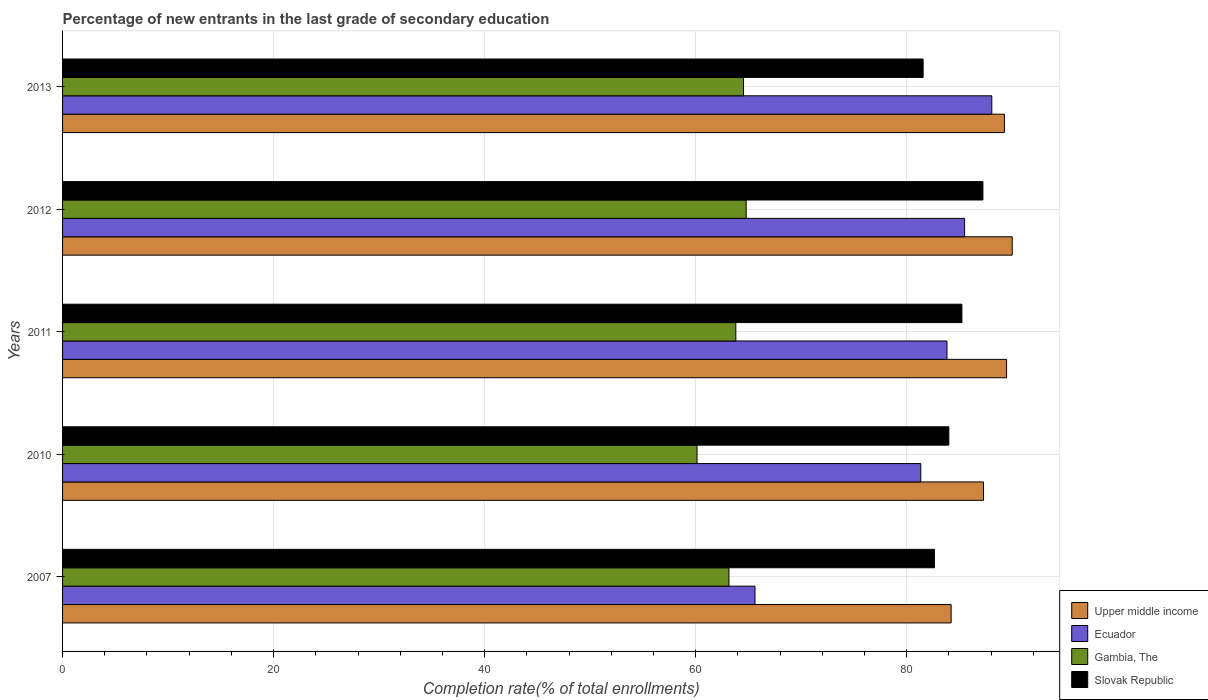How many different coloured bars are there?
Provide a succinct answer. 4. Are the number of bars on each tick of the Y-axis equal?
Provide a short and direct response. Yes. How many bars are there on the 4th tick from the top?
Offer a terse response. 4. How many bars are there on the 4th tick from the bottom?
Your answer should be very brief. 4. What is the label of the 3rd group of bars from the top?
Give a very brief answer. 2011. What is the percentage of new entrants in Slovak Republic in 2011?
Provide a short and direct response. 85.23. Across all years, what is the maximum percentage of new entrants in Slovak Republic?
Provide a short and direct response. 87.23. Across all years, what is the minimum percentage of new entrants in Upper middle income?
Your answer should be compact. 84.21. What is the total percentage of new entrants in Gambia, The in the graph?
Offer a terse response. 316.43. What is the difference between the percentage of new entrants in Slovak Republic in 2010 and that in 2012?
Offer a very short reply. -3.23. What is the difference between the percentage of new entrants in Upper middle income in 2013 and the percentage of new entrants in Ecuador in 2012?
Provide a short and direct response. 3.77. What is the average percentage of new entrants in Ecuador per year?
Your answer should be compact. 80.87. In the year 2013, what is the difference between the percentage of new entrants in Gambia, The and percentage of new entrants in Slovak Republic?
Your answer should be very brief. -17.02. What is the ratio of the percentage of new entrants in Slovak Republic in 2012 to that in 2013?
Provide a short and direct response. 1.07. Is the percentage of new entrants in Upper middle income in 2007 less than that in 2010?
Offer a very short reply. Yes. Is the difference between the percentage of new entrants in Gambia, The in 2007 and 2010 greater than the difference between the percentage of new entrants in Slovak Republic in 2007 and 2010?
Ensure brevity in your answer.  Yes. What is the difference between the highest and the second highest percentage of new entrants in Upper middle income?
Your response must be concise. 0.53. What is the difference between the highest and the lowest percentage of new entrants in Ecuador?
Provide a succinct answer. 22.44. In how many years, is the percentage of new entrants in Upper middle income greater than the average percentage of new entrants in Upper middle income taken over all years?
Your answer should be compact. 3. Is the sum of the percentage of new entrants in Gambia, The in 2007 and 2013 greater than the maximum percentage of new entrants in Upper middle income across all years?
Make the answer very short. Yes. Is it the case that in every year, the sum of the percentage of new entrants in Slovak Republic and percentage of new entrants in Ecuador is greater than the sum of percentage of new entrants in Upper middle income and percentage of new entrants in Gambia, The?
Your answer should be compact. No. What does the 1st bar from the top in 2007 represents?
Offer a terse response. Slovak Republic. What does the 2nd bar from the bottom in 2007 represents?
Make the answer very short. Ecuador. Is it the case that in every year, the sum of the percentage of new entrants in Gambia, The and percentage of new entrants in Upper middle income is greater than the percentage of new entrants in Slovak Republic?
Your answer should be compact. Yes. Are all the bars in the graph horizontal?
Make the answer very short. Yes. What is the difference between two consecutive major ticks on the X-axis?
Offer a very short reply. 20. How are the legend labels stacked?
Your response must be concise. Vertical. What is the title of the graph?
Give a very brief answer. Percentage of new entrants in the last grade of secondary education. What is the label or title of the X-axis?
Offer a very short reply. Completion rate(% of total enrollments). What is the label or title of the Y-axis?
Your answer should be very brief. Years. What is the Completion rate(% of total enrollments) in Upper middle income in 2007?
Your response must be concise. 84.21. What is the Completion rate(% of total enrollments) of Ecuador in 2007?
Your response must be concise. 65.63. What is the Completion rate(% of total enrollments) in Gambia, The in 2007?
Your response must be concise. 63.16. What is the Completion rate(% of total enrollments) in Slovak Republic in 2007?
Offer a very short reply. 82.63. What is the Completion rate(% of total enrollments) in Upper middle income in 2010?
Your response must be concise. 87.28. What is the Completion rate(% of total enrollments) in Ecuador in 2010?
Make the answer very short. 81.34. What is the Completion rate(% of total enrollments) of Gambia, The in 2010?
Give a very brief answer. 60.13. What is the Completion rate(% of total enrollments) of Slovak Republic in 2010?
Offer a very short reply. 84. What is the Completion rate(% of total enrollments) in Upper middle income in 2011?
Your response must be concise. 89.47. What is the Completion rate(% of total enrollments) in Ecuador in 2011?
Give a very brief answer. 83.82. What is the Completion rate(% of total enrollments) in Gambia, The in 2011?
Make the answer very short. 63.81. What is the Completion rate(% of total enrollments) in Slovak Republic in 2011?
Your answer should be compact. 85.23. What is the Completion rate(% of total enrollments) in Upper middle income in 2012?
Your answer should be compact. 90. What is the Completion rate(% of total enrollments) of Ecuador in 2012?
Offer a very short reply. 85.49. What is the Completion rate(% of total enrollments) of Gambia, The in 2012?
Ensure brevity in your answer.  64.79. What is the Completion rate(% of total enrollments) of Slovak Republic in 2012?
Offer a terse response. 87.23. What is the Completion rate(% of total enrollments) of Upper middle income in 2013?
Keep it short and to the point. 89.26. What is the Completion rate(% of total enrollments) of Ecuador in 2013?
Your answer should be very brief. 88.07. What is the Completion rate(% of total enrollments) in Gambia, The in 2013?
Offer a very short reply. 64.54. What is the Completion rate(% of total enrollments) of Slovak Republic in 2013?
Your response must be concise. 81.56. Across all years, what is the maximum Completion rate(% of total enrollments) in Upper middle income?
Provide a short and direct response. 90. Across all years, what is the maximum Completion rate(% of total enrollments) in Ecuador?
Offer a terse response. 88.07. Across all years, what is the maximum Completion rate(% of total enrollments) in Gambia, The?
Your answer should be very brief. 64.79. Across all years, what is the maximum Completion rate(% of total enrollments) in Slovak Republic?
Offer a terse response. 87.23. Across all years, what is the minimum Completion rate(% of total enrollments) of Upper middle income?
Your answer should be very brief. 84.21. Across all years, what is the minimum Completion rate(% of total enrollments) of Ecuador?
Give a very brief answer. 65.63. Across all years, what is the minimum Completion rate(% of total enrollments) of Gambia, The?
Offer a very short reply. 60.13. Across all years, what is the minimum Completion rate(% of total enrollments) of Slovak Republic?
Provide a succinct answer. 81.56. What is the total Completion rate(% of total enrollments) of Upper middle income in the graph?
Your answer should be very brief. 440.23. What is the total Completion rate(% of total enrollments) of Ecuador in the graph?
Offer a very short reply. 404.34. What is the total Completion rate(% of total enrollments) in Gambia, The in the graph?
Your answer should be very brief. 316.43. What is the total Completion rate(% of total enrollments) in Slovak Republic in the graph?
Your response must be concise. 420.65. What is the difference between the Completion rate(% of total enrollments) in Upper middle income in 2007 and that in 2010?
Your answer should be compact. -3.07. What is the difference between the Completion rate(% of total enrollments) in Ecuador in 2007 and that in 2010?
Provide a succinct answer. -15.71. What is the difference between the Completion rate(% of total enrollments) in Gambia, The in 2007 and that in 2010?
Ensure brevity in your answer.  3.02. What is the difference between the Completion rate(% of total enrollments) of Slovak Republic in 2007 and that in 2010?
Make the answer very short. -1.37. What is the difference between the Completion rate(% of total enrollments) in Upper middle income in 2007 and that in 2011?
Provide a succinct answer. -5.25. What is the difference between the Completion rate(% of total enrollments) of Ecuador in 2007 and that in 2011?
Ensure brevity in your answer.  -18.2. What is the difference between the Completion rate(% of total enrollments) of Gambia, The in 2007 and that in 2011?
Offer a terse response. -0.65. What is the difference between the Completion rate(% of total enrollments) in Slovak Republic in 2007 and that in 2011?
Offer a terse response. -2.6. What is the difference between the Completion rate(% of total enrollments) of Upper middle income in 2007 and that in 2012?
Ensure brevity in your answer.  -5.79. What is the difference between the Completion rate(% of total enrollments) of Ecuador in 2007 and that in 2012?
Your answer should be very brief. -19.86. What is the difference between the Completion rate(% of total enrollments) of Gambia, The in 2007 and that in 2012?
Provide a short and direct response. -1.63. What is the difference between the Completion rate(% of total enrollments) of Slovak Republic in 2007 and that in 2012?
Your answer should be compact. -4.6. What is the difference between the Completion rate(% of total enrollments) in Upper middle income in 2007 and that in 2013?
Keep it short and to the point. -5.05. What is the difference between the Completion rate(% of total enrollments) of Ecuador in 2007 and that in 2013?
Your answer should be very brief. -22.44. What is the difference between the Completion rate(% of total enrollments) in Gambia, The in 2007 and that in 2013?
Keep it short and to the point. -1.38. What is the difference between the Completion rate(% of total enrollments) in Slovak Republic in 2007 and that in 2013?
Your answer should be compact. 1.07. What is the difference between the Completion rate(% of total enrollments) of Upper middle income in 2010 and that in 2011?
Make the answer very short. -2.19. What is the difference between the Completion rate(% of total enrollments) of Ecuador in 2010 and that in 2011?
Your response must be concise. -2.48. What is the difference between the Completion rate(% of total enrollments) of Gambia, The in 2010 and that in 2011?
Keep it short and to the point. -3.67. What is the difference between the Completion rate(% of total enrollments) of Slovak Republic in 2010 and that in 2011?
Ensure brevity in your answer.  -1.24. What is the difference between the Completion rate(% of total enrollments) of Upper middle income in 2010 and that in 2012?
Provide a short and direct response. -2.72. What is the difference between the Completion rate(% of total enrollments) of Ecuador in 2010 and that in 2012?
Make the answer very short. -4.15. What is the difference between the Completion rate(% of total enrollments) in Gambia, The in 2010 and that in 2012?
Offer a terse response. -4.66. What is the difference between the Completion rate(% of total enrollments) in Slovak Republic in 2010 and that in 2012?
Give a very brief answer. -3.23. What is the difference between the Completion rate(% of total enrollments) in Upper middle income in 2010 and that in 2013?
Your answer should be compact. -1.98. What is the difference between the Completion rate(% of total enrollments) in Ecuador in 2010 and that in 2013?
Make the answer very short. -6.73. What is the difference between the Completion rate(% of total enrollments) in Gambia, The in 2010 and that in 2013?
Offer a terse response. -4.41. What is the difference between the Completion rate(% of total enrollments) of Slovak Republic in 2010 and that in 2013?
Give a very brief answer. 2.44. What is the difference between the Completion rate(% of total enrollments) in Upper middle income in 2011 and that in 2012?
Your answer should be very brief. -0.53. What is the difference between the Completion rate(% of total enrollments) of Ecuador in 2011 and that in 2012?
Provide a short and direct response. -1.67. What is the difference between the Completion rate(% of total enrollments) in Gambia, The in 2011 and that in 2012?
Your answer should be very brief. -0.98. What is the difference between the Completion rate(% of total enrollments) in Slovak Republic in 2011 and that in 2012?
Provide a short and direct response. -1.99. What is the difference between the Completion rate(% of total enrollments) of Upper middle income in 2011 and that in 2013?
Keep it short and to the point. 0.2. What is the difference between the Completion rate(% of total enrollments) in Ecuador in 2011 and that in 2013?
Give a very brief answer. -4.25. What is the difference between the Completion rate(% of total enrollments) in Gambia, The in 2011 and that in 2013?
Your answer should be very brief. -0.73. What is the difference between the Completion rate(% of total enrollments) in Slovak Republic in 2011 and that in 2013?
Offer a very short reply. 3.67. What is the difference between the Completion rate(% of total enrollments) in Upper middle income in 2012 and that in 2013?
Offer a very short reply. 0.74. What is the difference between the Completion rate(% of total enrollments) of Ecuador in 2012 and that in 2013?
Make the answer very short. -2.58. What is the difference between the Completion rate(% of total enrollments) of Gambia, The in 2012 and that in 2013?
Provide a short and direct response. 0.25. What is the difference between the Completion rate(% of total enrollments) in Slovak Republic in 2012 and that in 2013?
Provide a short and direct response. 5.67. What is the difference between the Completion rate(% of total enrollments) in Upper middle income in 2007 and the Completion rate(% of total enrollments) in Ecuador in 2010?
Provide a succinct answer. 2.88. What is the difference between the Completion rate(% of total enrollments) in Upper middle income in 2007 and the Completion rate(% of total enrollments) in Gambia, The in 2010?
Offer a terse response. 24.08. What is the difference between the Completion rate(% of total enrollments) in Upper middle income in 2007 and the Completion rate(% of total enrollments) in Slovak Republic in 2010?
Provide a succinct answer. 0.22. What is the difference between the Completion rate(% of total enrollments) in Ecuador in 2007 and the Completion rate(% of total enrollments) in Gambia, The in 2010?
Make the answer very short. 5.49. What is the difference between the Completion rate(% of total enrollments) in Ecuador in 2007 and the Completion rate(% of total enrollments) in Slovak Republic in 2010?
Your answer should be very brief. -18.37. What is the difference between the Completion rate(% of total enrollments) of Gambia, The in 2007 and the Completion rate(% of total enrollments) of Slovak Republic in 2010?
Provide a short and direct response. -20.84. What is the difference between the Completion rate(% of total enrollments) of Upper middle income in 2007 and the Completion rate(% of total enrollments) of Ecuador in 2011?
Your answer should be very brief. 0.39. What is the difference between the Completion rate(% of total enrollments) in Upper middle income in 2007 and the Completion rate(% of total enrollments) in Gambia, The in 2011?
Give a very brief answer. 20.41. What is the difference between the Completion rate(% of total enrollments) of Upper middle income in 2007 and the Completion rate(% of total enrollments) of Slovak Republic in 2011?
Your response must be concise. -1.02. What is the difference between the Completion rate(% of total enrollments) in Ecuador in 2007 and the Completion rate(% of total enrollments) in Gambia, The in 2011?
Your response must be concise. 1.82. What is the difference between the Completion rate(% of total enrollments) in Ecuador in 2007 and the Completion rate(% of total enrollments) in Slovak Republic in 2011?
Make the answer very short. -19.61. What is the difference between the Completion rate(% of total enrollments) of Gambia, The in 2007 and the Completion rate(% of total enrollments) of Slovak Republic in 2011?
Your answer should be compact. -22.08. What is the difference between the Completion rate(% of total enrollments) of Upper middle income in 2007 and the Completion rate(% of total enrollments) of Ecuador in 2012?
Offer a terse response. -1.28. What is the difference between the Completion rate(% of total enrollments) of Upper middle income in 2007 and the Completion rate(% of total enrollments) of Gambia, The in 2012?
Your answer should be very brief. 19.43. What is the difference between the Completion rate(% of total enrollments) of Upper middle income in 2007 and the Completion rate(% of total enrollments) of Slovak Republic in 2012?
Your answer should be compact. -3.01. What is the difference between the Completion rate(% of total enrollments) in Ecuador in 2007 and the Completion rate(% of total enrollments) in Gambia, The in 2012?
Offer a terse response. 0.84. What is the difference between the Completion rate(% of total enrollments) in Ecuador in 2007 and the Completion rate(% of total enrollments) in Slovak Republic in 2012?
Offer a terse response. -21.6. What is the difference between the Completion rate(% of total enrollments) of Gambia, The in 2007 and the Completion rate(% of total enrollments) of Slovak Republic in 2012?
Make the answer very short. -24.07. What is the difference between the Completion rate(% of total enrollments) of Upper middle income in 2007 and the Completion rate(% of total enrollments) of Ecuador in 2013?
Your answer should be very brief. -3.86. What is the difference between the Completion rate(% of total enrollments) of Upper middle income in 2007 and the Completion rate(% of total enrollments) of Gambia, The in 2013?
Ensure brevity in your answer.  19.67. What is the difference between the Completion rate(% of total enrollments) of Upper middle income in 2007 and the Completion rate(% of total enrollments) of Slovak Republic in 2013?
Provide a succinct answer. 2.65. What is the difference between the Completion rate(% of total enrollments) of Ecuador in 2007 and the Completion rate(% of total enrollments) of Gambia, The in 2013?
Give a very brief answer. 1.09. What is the difference between the Completion rate(% of total enrollments) in Ecuador in 2007 and the Completion rate(% of total enrollments) in Slovak Republic in 2013?
Provide a short and direct response. -15.93. What is the difference between the Completion rate(% of total enrollments) in Gambia, The in 2007 and the Completion rate(% of total enrollments) in Slovak Republic in 2013?
Your response must be concise. -18.4. What is the difference between the Completion rate(% of total enrollments) of Upper middle income in 2010 and the Completion rate(% of total enrollments) of Ecuador in 2011?
Offer a terse response. 3.46. What is the difference between the Completion rate(% of total enrollments) of Upper middle income in 2010 and the Completion rate(% of total enrollments) of Gambia, The in 2011?
Make the answer very short. 23.47. What is the difference between the Completion rate(% of total enrollments) of Upper middle income in 2010 and the Completion rate(% of total enrollments) of Slovak Republic in 2011?
Ensure brevity in your answer.  2.05. What is the difference between the Completion rate(% of total enrollments) in Ecuador in 2010 and the Completion rate(% of total enrollments) in Gambia, The in 2011?
Your answer should be compact. 17.53. What is the difference between the Completion rate(% of total enrollments) of Ecuador in 2010 and the Completion rate(% of total enrollments) of Slovak Republic in 2011?
Offer a very short reply. -3.9. What is the difference between the Completion rate(% of total enrollments) in Gambia, The in 2010 and the Completion rate(% of total enrollments) in Slovak Republic in 2011?
Ensure brevity in your answer.  -25.1. What is the difference between the Completion rate(% of total enrollments) of Upper middle income in 2010 and the Completion rate(% of total enrollments) of Ecuador in 2012?
Ensure brevity in your answer.  1.79. What is the difference between the Completion rate(% of total enrollments) of Upper middle income in 2010 and the Completion rate(% of total enrollments) of Gambia, The in 2012?
Offer a terse response. 22.49. What is the difference between the Completion rate(% of total enrollments) in Upper middle income in 2010 and the Completion rate(% of total enrollments) in Slovak Republic in 2012?
Offer a terse response. 0.05. What is the difference between the Completion rate(% of total enrollments) in Ecuador in 2010 and the Completion rate(% of total enrollments) in Gambia, The in 2012?
Make the answer very short. 16.55. What is the difference between the Completion rate(% of total enrollments) of Ecuador in 2010 and the Completion rate(% of total enrollments) of Slovak Republic in 2012?
Offer a very short reply. -5.89. What is the difference between the Completion rate(% of total enrollments) in Gambia, The in 2010 and the Completion rate(% of total enrollments) in Slovak Republic in 2012?
Provide a short and direct response. -27.09. What is the difference between the Completion rate(% of total enrollments) of Upper middle income in 2010 and the Completion rate(% of total enrollments) of Ecuador in 2013?
Give a very brief answer. -0.79. What is the difference between the Completion rate(% of total enrollments) in Upper middle income in 2010 and the Completion rate(% of total enrollments) in Gambia, The in 2013?
Ensure brevity in your answer.  22.74. What is the difference between the Completion rate(% of total enrollments) of Upper middle income in 2010 and the Completion rate(% of total enrollments) of Slovak Republic in 2013?
Your answer should be very brief. 5.72. What is the difference between the Completion rate(% of total enrollments) in Ecuador in 2010 and the Completion rate(% of total enrollments) in Gambia, The in 2013?
Offer a terse response. 16.8. What is the difference between the Completion rate(% of total enrollments) in Ecuador in 2010 and the Completion rate(% of total enrollments) in Slovak Republic in 2013?
Your response must be concise. -0.22. What is the difference between the Completion rate(% of total enrollments) of Gambia, The in 2010 and the Completion rate(% of total enrollments) of Slovak Republic in 2013?
Your response must be concise. -21.43. What is the difference between the Completion rate(% of total enrollments) in Upper middle income in 2011 and the Completion rate(% of total enrollments) in Ecuador in 2012?
Offer a very short reply. 3.98. What is the difference between the Completion rate(% of total enrollments) of Upper middle income in 2011 and the Completion rate(% of total enrollments) of Gambia, The in 2012?
Ensure brevity in your answer.  24.68. What is the difference between the Completion rate(% of total enrollments) of Upper middle income in 2011 and the Completion rate(% of total enrollments) of Slovak Republic in 2012?
Provide a short and direct response. 2.24. What is the difference between the Completion rate(% of total enrollments) of Ecuador in 2011 and the Completion rate(% of total enrollments) of Gambia, The in 2012?
Offer a terse response. 19.03. What is the difference between the Completion rate(% of total enrollments) of Ecuador in 2011 and the Completion rate(% of total enrollments) of Slovak Republic in 2012?
Make the answer very short. -3.41. What is the difference between the Completion rate(% of total enrollments) in Gambia, The in 2011 and the Completion rate(% of total enrollments) in Slovak Republic in 2012?
Provide a short and direct response. -23.42. What is the difference between the Completion rate(% of total enrollments) of Upper middle income in 2011 and the Completion rate(% of total enrollments) of Ecuador in 2013?
Give a very brief answer. 1.4. What is the difference between the Completion rate(% of total enrollments) of Upper middle income in 2011 and the Completion rate(% of total enrollments) of Gambia, The in 2013?
Your response must be concise. 24.93. What is the difference between the Completion rate(% of total enrollments) in Upper middle income in 2011 and the Completion rate(% of total enrollments) in Slovak Republic in 2013?
Ensure brevity in your answer.  7.91. What is the difference between the Completion rate(% of total enrollments) in Ecuador in 2011 and the Completion rate(% of total enrollments) in Gambia, The in 2013?
Provide a short and direct response. 19.28. What is the difference between the Completion rate(% of total enrollments) in Ecuador in 2011 and the Completion rate(% of total enrollments) in Slovak Republic in 2013?
Ensure brevity in your answer.  2.26. What is the difference between the Completion rate(% of total enrollments) in Gambia, The in 2011 and the Completion rate(% of total enrollments) in Slovak Republic in 2013?
Make the answer very short. -17.75. What is the difference between the Completion rate(% of total enrollments) in Upper middle income in 2012 and the Completion rate(% of total enrollments) in Ecuador in 2013?
Your response must be concise. 1.93. What is the difference between the Completion rate(% of total enrollments) in Upper middle income in 2012 and the Completion rate(% of total enrollments) in Gambia, The in 2013?
Provide a succinct answer. 25.46. What is the difference between the Completion rate(% of total enrollments) in Upper middle income in 2012 and the Completion rate(% of total enrollments) in Slovak Republic in 2013?
Make the answer very short. 8.44. What is the difference between the Completion rate(% of total enrollments) of Ecuador in 2012 and the Completion rate(% of total enrollments) of Gambia, The in 2013?
Your response must be concise. 20.95. What is the difference between the Completion rate(% of total enrollments) in Ecuador in 2012 and the Completion rate(% of total enrollments) in Slovak Republic in 2013?
Offer a very short reply. 3.93. What is the difference between the Completion rate(% of total enrollments) of Gambia, The in 2012 and the Completion rate(% of total enrollments) of Slovak Republic in 2013?
Ensure brevity in your answer.  -16.77. What is the average Completion rate(% of total enrollments) in Upper middle income per year?
Your answer should be very brief. 88.05. What is the average Completion rate(% of total enrollments) of Ecuador per year?
Make the answer very short. 80.87. What is the average Completion rate(% of total enrollments) of Gambia, The per year?
Your answer should be compact. 63.29. What is the average Completion rate(% of total enrollments) of Slovak Republic per year?
Provide a succinct answer. 84.13. In the year 2007, what is the difference between the Completion rate(% of total enrollments) in Upper middle income and Completion rate(% of total enrollments) in Ecuador?
Ensure brevity in your answer.  18.59. In the year 2007, what is the difference between the Completion rate(% of total enrollments) of Upper middle income and Completion rate(% of total enrollments) of Gambia, The?
Your answer should be compact. 21.06. In the year 2007, what is the difference between the Completion rate(% of total enrollments) in Upper middle income and Completion rate(% of total enrollments) in Slovak Republic?
Offer a terse response. 1.58. In the year 2007, what is the difference between the Completion rate(% of total enrollments) of Ecuador and Completion rate(% of total enrollments) of Gambia, The?
Ensure brevity in your answer.  2.47. In the year 2007, what is the difference between the Completion rate(% of total enrollments) of Ecuador and Completion rate(% of total enrollments) of Slovak Republic?
Make the answer very short. -17.01. In the year 2007, what is the difference between the Completion rate(% of total enrollments) in Gambia, The and Completion rate(% of total enrollments) in Slovak Republic?
Your answer should be very brief. -19.47. In the year 2010, what is the difference between the Completion rate(% of total enrollments) of Upper middle income and Completion rate(% of total enrollments) of Ecuador?
Your answer should be very brief. 5.95. In the year 2010, what is the difference between the Completion rate(% of total enrollments) of Upper middle income and Completion rate(% of total enrollments) of Gambia, The?
Give a very brief answer. 27.15. In the year 2010, what is the difference between the Completion rate(% of total enrollments) of Upper middle income and Completion rate(% of total enrollments) of Slovak Republic?
Offer a very short reply. 3.28. In the year 2010, what is the difference between the Completion rate(% of total enrollments) of Ecuador and Completion rate(% of total enrollments) of Gambia, The?
Provide a succinct answer. 21.2. In the year 2010, what is the difference between the Completion rate(% of total enrollments) in Ecuador and Completion rate(% of total enrollments) in Slovak Republic?
Provide a short and direct response. -2.66. In the year 2010, what is the difference between the Completion rate(% of total enrollments) in Gambia, The and Completion rate(% of total enrollments) in Slovak Republic?
Provide a short and direct response. -23.86. In the year 2011, what is the difference between the Completion rate(% of total enrollments) in Upper middle income and Completion rate(% of total enrollments) in Ecuador?
Ensure brevity in your answer.  5.65. In the year 2011, what is the difference between the Completion rate(% of total enrollments) in Upper middle income and Completion rate(% of total enrollments) in Gambia, The?
Your answer should be very brief. 25.66. In the year 2011, what is the difference between the Completion rate(% of total enrollments) of Upper middle income and Completion rate(% of total enrollments) of Slovak Republic?
Give a very brief answer. 4.23. In the year 2011, what is the difference between the Completion rate(% of total enrollments) in Ecuador and Completion rate(% of total enrollments) in Gambia, The?
Keep it short and to the point. 20.01. In the year 2011, what is the difference between the Completion rate(% of total enrollments) in Ecuador and Completion rate(% of total enrollments) in Slovak Republic?
Your response must be concise. -1.41. In the year 2011, what is the difference between the Completion rate(% of total enrollments) in Gambia, The and Completion rate(% of total enrollments) in Slovak Republic?
Ensure brevity in your answer.  -21.43. In the year 2012, what is the difference between the Completion rate(% of total enrollments) in Upper middle income and Completion rate(% of total enrollments) in Ecuador?
Ensure brevity in your answer.  4.51. In the year 2012, what is the difference between the Completion rate(% of total enrollments) in Upper middle income and Completion rate(% of total enrollments) in Gambia, The?
Keep it short and to the point. 25.21. In the year 2012, what is the difference between the Completion rate(% of total enrollments) in Upper middle income and Completion rate(% of total enrollments) in Slovak Republic?
Make the answer very short. 2.78. In the year 2012, what is the difference between the Completion rate(% of total enrollments) in Ecuador and Completion rate(% of total enrollments) in Gambia, The?
Make the answer very short. 20.7. In the year 2012, what is the difference between the Completion rate(% of total enrollments) of Ecuador and Completion rate(% of total enrollments) of Slovak Republic?
Your response must be concise. -1.74. In the year 2012, what is the difference between the Completion rate(% of total enrollments) of Gambia, The and Completion rate(% of total enrollments) of Slovak Republic?
Your answer should be very brief. -22.44. In the year 2013, what is the difference between the Completion rate(% of total enrollments) of Upper middle income and Completion rate(% of total enrollments) of Ecuador?
Make the answer very short. 1.19. In the year 2013, what is the difference between the Completion rate(% of total enrollments) of Upper middle income and Completion rate(% of total enrollments) of Gambia, The?
Your response must be concise. 24.72. In the year 2013, what is the difference between the Completion rate(% of total enrollments) of Upper middle income and Completion rate(% of total enrollments) of Slovak Republic?
Keep it short and to the point. 7.7. In the year 2013, what is the difference between the Completion rate(% of total enrollments) of Ecuador and Completion rate(% of total enrollments) of Gambia, The?
Provide a succinct answer. 23.53. In the year 2013, what is the difference between the Completion rate(% of total enrollments) of Ecuador and Completion rate(% of total enrollments) of Slovak Republic?
Offer a terse response. 6.51. In the year 2013, what is the difference between the Completion rate(% of total enrollments) in Gambia, The and Completion rate(% of total enrollments) in Slovak Republic?
Make the answer very short. -17.02. What is the ratio of the Completion rate(% of total enrollments) of Upper middle income in 2007 to that in 2010?
Offer a very short reply. 0.96. What is the ratio of the Completion rate(% of total enrollments) in Ecuador in 2007 to that in 2010?
Offer a terse response. 0.81. What is the ratio of the Completion rate(% of total enrollments) of Gambia, The in 2007 to that in 2010?
Your response must be concise. 1.05. What is the ratio of the Completion rate(% of total enrollments) of Slovak Republic in 2007 to that in 2010?
Make the answer very short. 0.98. What is the ratio of the Completion rate(% of total enrollments) of Upper middle income in 2007 to that in 2011?
Keep it short and to the point. 0.94. What is the ratio of the Completion rate(% of total enrollments) of Ecuador in 2007 to that in 2011?
Your response must be concise. 0.78. What is the ratio of the Completion rate(% of total enrollments) of Gambia, The in 2007 to that in 2011?
Ensure brevity in your answer.  0.99. What is the ratio of the Completion rate(% of total enrollments) in Slovak Republic in 2007 to that in 2011?
Provide a succinct answer. 0.97. What is the ratio of the Completion rate(% of total enrollments) in Upper middle income in 2007 to that in 2012?
Offer a terse response. 0.94. What is the ratio of the Completion rate(% of total enrollments) in Ecuador in 2007 to that in 2012?
Your answer should be very brief. 0.77. What is the ratio of the Completion rate(% of total enrollments) in Gambia, The in 2007 to that in 2012?
Provide a short and direct response. 0.97. What is the ratio of the Completion rate(% of total enrollments) in Slovak Republic in 2007 to that in 2012?
Offer a very short reply. 0.95. What is the ratio of the Completion rate(% of total enrollments) in Upper middle income in 2007 to that in 2013?
Your answer should be very brief. 0.94. What is the ratio of the Completion rate(% of total enrollments) in Ecuador in 2007 to that in 2013?
Your answer should be compact. 0.75. What is the ratio of the Completion rate(% of total enrollments) in Gambia, The in 2007 to that in 2013?
Your answer should be compact. 0.98. What is the ratio of the Completion rate(% of total enrollments) in Slovak Republic in 2007 to that in 2013?
Keep it short and to the point. 1.01. What is the ratio of the Completion rate(% of total enrollments) in Upper middle income in 2010 to that in 2011?
Give a very brief answer. 0.98. What is the ratio of the Completion rate(% of total enrollments) in Ecuador in 2010 to that in 2011?
Provide a succinct answer. 0.97. What is the ratio of the Completion rate(% of total enrollments) in Gambia, The in 2010 to that in 2011?
Your answer should be compact. 0.94. What is the ratio of the Completion rate(% of total enrollments) of Slovak Republic in 2010 to that in 2011?
Your answer should be compact. 0.99. What is the ratio of the Completion rate(% of total enrollments) of Upper middle income in 2010 to that in 2012?
Keep it short and to the point. 0.97. What is the ratio of the Completion rate(% of total enrollments) in Ecuador in 2010 to that in 2012?
Offer a terse response. 0.95. What is the ratio of the Completion rate(% of total enrollments) of Gambia, The in 2010 to that in 2012?
Provide a short and direct response. 0.93. What is the ratio of the Completion rate(% of total enrollments) in Upper middle income in 2010 to that in 2013?
Your response must be concise. 0.98. What is the ratio of the Completion rate(% of total enrollments) in Ecuador in 2010 to that in 2013?
Provide a succinct answer. 0.92. What is the ratio of the Completion rate(% of total enrollments) of Gambia, The in 2010 to that in 2013?
Ensure brevity in your answer.  0.93. What is the ratio of the Completion rate(% of total enrollments) of Slovak Republic in 2010 to that in 2013?
Ensure brevity in your answer.  1.03. What is the ratio of the Completion rate(% of total enrollments) in Ecuador in 2011 to that in 2012?
Your answer should be very brief. 0.98. What is the ratio of the Completion rate(% of total enrollments) in Gambia, The in 2011 to that in 2012?
Provide a short and direct response. 0.98. What is the ratio of the Completion rate(% of total enrollments) of Slovak Republic in 2011 to that in 2012?
Your answer should be compact. 0.98. What is the ratio of the Completion rate(% of total enrollments) in Ecuador in 2011 to that in 2013?
Provide a succinct answer. 0.95. What is the ratio of the Completion rate(% of total enrollments) in Gambia, The in 2011 to that in 2013?
Provide a short and direct response. 0.99. What is the ratio of the Completion rate(% of total enrollments) in Slovak Republic in 2011 to that in 2013?
Ensure brevity in your answer.  1.05. What is the ratio of the Completion rate(% of total enrollments) of Upper middle income in 2012 to that in 2013?
Your response must be concise. 1.01. What is the ratio of the Completion rate(% of total enrollments) of Ecuador in 2012 to that in 2013?
Ensure brevity in your answer.  0.97. What is the ratio of the Completion rate(% of total enrollments) of Slovak Republic in 2012 to that in 2013?
Your response must be concise. 1.07. What is the difference between the highest and the second highest Completion rate(% of total enrollments) in Upper middle income?
Keep it short and to the point. 0.53. What is the difference between the highest and the second highest Completion rate(% of total enrollments) of Ecuador?
Keep it short and to the point. 2.58. What is the difference between the highest and the second highest Completion rate(% of total enrollments) in Gambia, The?
Provide a succinct answer. 0.25. What is the difference between the highest and the second highest Completion rate(% of total enrollments) of Slovak Republic?
Provide a short and direct response. 1.99. What is the difference between the highest and the lowest Completion rate(% of total enrollments) in Upper middle income?
Your response must be concise. 5.79. What is the difference between the highest and the lowest Completion rate(% of total enrollments) of Ecuador?
Offer a terse response. 22.44. What is the difference between the highest and the lowest Completion rate(% of total enrollments) of Gambia, The?
Make the answer very short. 4.66. What is the difference between the highest and the lowest Completion rate(% of total enrollments) in Slovak Republic?
Ensure brevity in your answer.  5.67. 